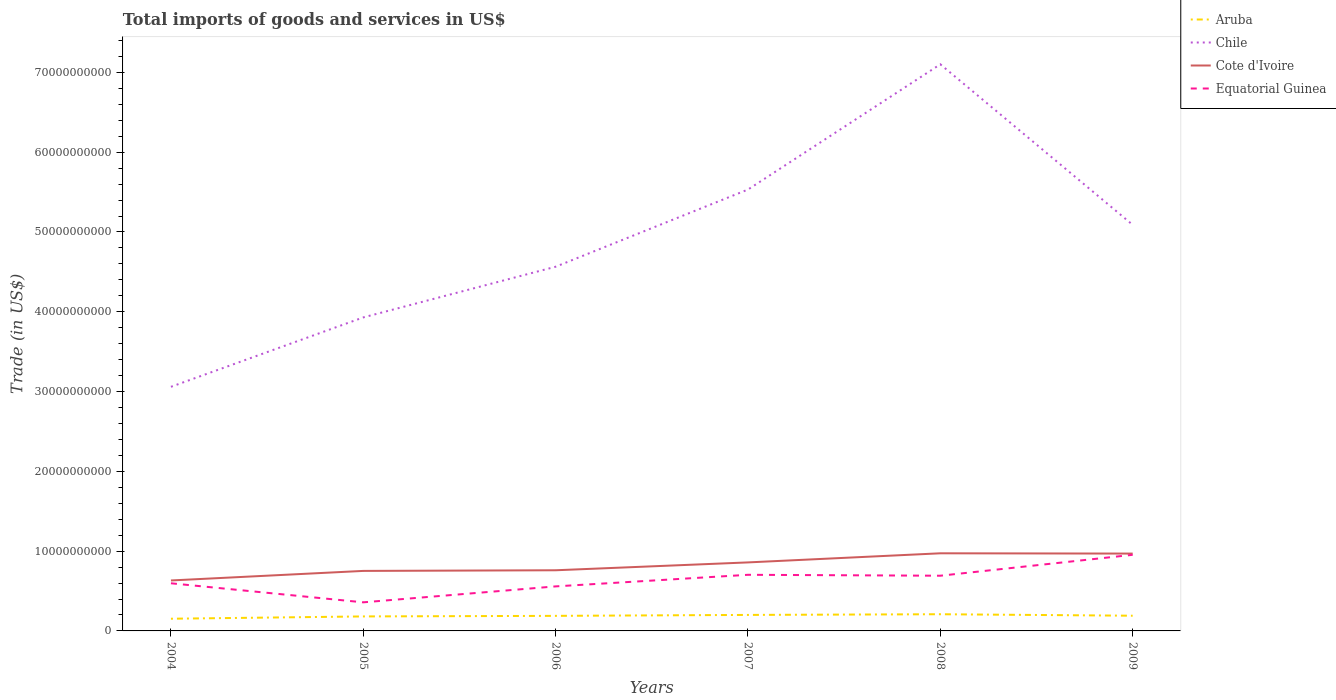Does the line corresponding to Equatorial Guinea intersect with the line corresponding to Aruba?
Your answer should be very brief. No. Across all years, what is the maximum total imports of goods and services in Aruba?
Provide a short and direct response. 1.53e+09. What is the total total imports of goods and services in Aruba in the graph?
Your response must be concise. -2.89e+08. What is the difference between the highest and the second highest total imports of goods and services in Aruba?
Your response must be concise. 5.64e+08. What is the difference between the highest and the lowest total imports of goods and services in Cote d'Ivoire?
Keep it short and to the point. 3. Is the total imports of goods and services in Cote d'Ivoire strictly greater than the total imports of goods and services in Equatorial Guinea over the years?
Keep it short and to the point. No. What is the difference between two consecutive major ticks on the Y-axis?
Your response must be concise. 1.00e+1. Does the graph contain any zero values?
Make the answer very short. No. How many legend labels are there?
Give a very brief answer. 4. How are the legend labels stacked?
Give a very brief answer. Vertical. What is the title of the graph?
Give a very brief answer. Total imports of goods and services in US$. What is the label or title of the X-axis?
Make the answer very short. Years. What is the label or title of the Y-axis?
Keep it short and to the point. Trade (in US$). What is the Trade (in US$) of Aruba in 2004?
Provide a short and direct response. 1.53e+09. What is the Trade (in US$) in Chile in 2004?
Offer a terse response. 3.06e+1. What is the Trade (in US$) of Cote d'Ivoire in 2004?
Give a very brief answer. 6.32e+09. What is the Trade (in US$) in Equatorial Guinea in 2004?
Give a very brief answer. 5.97e+09. What is the Trade (in US$) in Aruba in 2005?
Your response must be concise. 1.82e+09. What is the Trade (in US$) of Chile in 2005?
Keep it short and to the point. 3.93e+1. What is the Trade (in US$) of Cote d'Ivoire in 2005?
Offer a terse response. 7.52e+09. What is the Trade (in US$) of Equatorial Guinea in 2005?
Your answer should be very brief. 3.58e+09. What is the Trade (in US$) in Aruba in 2006?
Offer a terse response. 1.89e+09. What is the Trade (in US$) of Chile in 2006?
Provide a succinct answer. 4.56e+1. What is the Trade (in US$) in Cote d'Ivoire in 2006?
Make the answer very short. 7.60e+09. What is the Trade (in US$) of Equatorial Guinea in 2006?
Provide a succinct answer. 5.58e+09. What is the Trade (in US$) in Aruba in 2007?
Your response must be concise. 2.01e+09. What is the Trade (in US$) in Chile in 2007?
Offer a very short reply. 5.53e+1. What is the Trade (in US$) in Cote d'Ivoire in 2007?
Your response must be concise. 8.59e+09. What is the Trade (in US$) in Equatorial Guinea in 2007?
Your answer should be compact. 7.03e+09. What is the Trade (in US$) of Aruba in 2008?
Keep it short and to the point. 2.09e+09. What is the Trade (in US$) of Chile in 2008?
Keep it short and to the point. 7.10e+1. What is the Trade (in US$) in Cote d'Ivoire in 2008?
Offer a very short reply. 9.73e+09. What is the Trade (in US$) in Equatorial Guinea in 2008?
Provide a short and direct response. 6.92e+09. What is the Trade (in US$) of Aruba in 2009?
Ensure brevity in your answer.  1.91e+09. What is the Trade (in US$) of Chile in 2009?
Your answer should be compact. 5.09e+1. What is the Trade (in US$) of Cote d'Ivoire in 2009?
Provide a short and direct response. 9.69e+09. What is the Trade (in US$) in Equatorial Guinea in 2009?
Make the answer very short. 9.54e+09. Across all years, what is the maximum Trade (in US$) in Aruba?
Make the answer very short. 2.09e+09. Across all years, what is the maximum Trade (in US$) of Chile?
Give a very brief answer. 7.10e+1. Across all years, what is the maximum Trade (in US$) in Cote d'Ivoire?
Keep it short and to the point. 9.73e+09. Across all years, what is the maximum Trade (in US$) of Equatorial Guinea?
Keep it short and to the point. 9.54e+09. Across all years, what is the minimum Trade (in US$) in Aruba?
Keep it short and to the point. 1.53e+09. Across all years, what is the minimum Trade (in US$) of Chile?
Your answer should be compact. 3.06e+1. Across all years, what is the minimum Trade (in US$) of Cote d'Ivoire?
Provide a succinct answer. 6.32e+09. Across all years, what is the minimum Trade (in US$) in Equatorial Guinea?
Your response must be concise. 3.58e+09. What is the total Trade (in US$) in Aruba in the graph?
Ensure brevity in your answer.  1.12e+1. What is the total Trade (in US$) in Chile in the graph?
Offer a very short reply. 2.93e+11. What is the total Trade (in US$) in Cote d'Ivoire in the graph?
Provide a succinct answer. 4.95e+1. What is the total Trade (in US$) of Equatorial Guinea in the graph?
Keep it short and to the point. 3.86e+1. What is the difference between the Trade (in US$) of Aruba in 2004 and that in 2005?
Offer a very short reply. -2.89e+08. What is the difference between the Trade (in US$) in Chile in 2004 and that in 2005?
Ensure brevity in your answer.  -8.70e+09. What is the difference between the Trade (in US$) of Cote d'Ivoire in 2004 and that in 2005?
Offer a very short reply. -1.20e+09. What is the difference between the Trade (in US$) of Equatorial Guinea in 2004 and that in 2005?
Offer a very short reply. 2.39e+09. What is the difference between the Trade (in US$) in Aruba in 2004 and that in 2006?
Offer a terse response. -3.60e+08. What is the difference between the Trade (in US$) in Chile in 2004 and that in 2006?
Offer a terse response. -1.50e+1. What is the difference between the Trade (in US$) in Cote d'Ivoire in 2004 and that in 2006?
Provide a short and direct response. -1.28e+09. What is the difference between the Trade (in US$) of Equatorial Guinea in 2004 and that in 2006?
Provide a succinct answer. 3.90e+08. What is the difference between the Trade (in US$) in Aruba in 2004 and that in 2007?
Offer a terse response. -4.78e+08. What is the difference between the Trade (in US$) in Chile in 2004 and that in 2007?
Ensure brevity in your answer.  -2.47e+1. What is the difference between the Trade (in US$) of Cote d'Ivoire in 2004 and that in 2007?
Offer a very short reply. -2.26e+09. What is the difference between the Trade (in US$) in Equatorial Guinea in 2004 and that in 2007?
Keep it short and to the point. -1.06e+09. What is the difference between the Trade (in US$) in Aruba in 2004 and that in 2008?
Your response must be concise. -5.64e+08. What is the difference between the Trade (in US$) of Chile in 2004 and that in 2008?
Make the answer very short. -4.04e+1. What is the difference between the Trade (in US$) in Cote d'Ivoire in 2004 and that in 2008?
Your answer should be very brief. -3.40e+09. What is the difference between the Trade (in US$) in Equatorial Guinea in 2004 and that in 2008?
Offer a very short reply. -9.47e+08. What is the difference between the Trade (in US$) of Aruba in 2004 and that in 2009?
Ensure brevity in your answer.  -3.78e+08. What is the difference between the Trade (in US$) in Chile in 2004 and that in 2009?
Offer a terse response. -2.03e+1. What is the difference between the Trade (in US$) in Cote d'Ivoire in 2004 and that in 2009?
Keep it short and to the point. -3.37e+09. What is the difference between the Trade (in US$) in Equatorial Guinea in 2004 and that in 2009?
Keep it short and to the point. -3.57e+09. What is the difference between the Trade (in US$) in Aruba in 2005 and that in 2006?
Your response must be concise. -7.15e+07. What is the difference between the Trade (in US$) in Chile in 2005 and that in 2006?
Give a very brief answer. -6.35e+09. What is the difference between the Trade (in US$) of Cote d'Ivoire in 2005 and that in 2006?
Keep it short and to the point. -7.98e+07. What is the difference between the Trade (in US$) in Equatorial Guinea in 2005 and that in 2006?
Provide a short and direct response. -2.00e+09. What is the difference between the Trade (in US$) of Aruba in 2005 and that in 2007?
Ensure brevity in your answer.  -1.89e+08. What is the difference between the Trade (in US$) in Chile in 2005 and that in 2007?
Offer a terse response. -1.60e+1. What is the difference between the Trade (in US$) of Cote d'Ivoire in 2005 and that in 2007?
Offer a terse response. -1.07e+09. What is the difference between the Trade (in US$) in Equatorial Guinea in 2005 and that in 2007?
Offer a very short reply. -3.45e+09. What is the difference between the Trade (in US$) of Aruba in 2005 and that in 2008?
Ensure brevity in your answer.  -2.75e+08. What is the difference between the Trade (in US$) in Chile in 2005 and that in 2008?
Provide a succinct answer. -3.17e+1. What is the difference between the Trade (in US$) of Cote d'Ivoire in 2005 and that in 2008?
Make the answer very short. -2.21e+09. What is the difference between the Trade (in US$) of Equatorial Guinea in 2005 and that in 2008?
Give a very brief answer. -3.34e+09. What is the difference between the Trade (in US$) in Aruba in 2005 and that in 2009?
Your response must be concise. -8.95e+07. What is the difference between the Trade (in US$) of Chile in 2005 and that in 2009?
Offer a terse response. -1.16e+1. What is the difference between the Trade (in US$) of Cote d'Ivoire in 2005 and that in 2009?
Provide a short and direct response. -2.17e+09. What is the difference between the Trade (in US$) in Equatorial Guinea in 2005 and that in 2009?
Your answer should be compact. -5.96e+09. What is the difference between the Trade (in US$) of Aruba in 2006 and that in 2007?
Give a very brief answer. -1.18e+08. What is the difference between the Trade (in US$) in Chile in 2006 and that in 2007?
Your answer should be compact. -9.67e+09. What is the difference between the Trade (in US$) in Cote d'Ivoire in 2006 and that in 2007?
Provide a short and direct response. -9.86e+08. What is the difference between the Trade (in US$) of Equatorial Guinea in 2006 and that in 2007?
Your answer should be very brief. -1.45e+09. What is the difference between the Trade (in US$) of Aruba in 2006 and that in 2008?
Your answer should be very brief. -2.04e+08. What is the difference between the Trade (in US$) in Chile in 2006 and that in 2008?
Your response must be concise. -2.54e+1. What is the difference between the Trade (in US$) in Cote d'Ivoire in 2006 and that in 2008?
Provide a succinct answer. -2.13e+09. What is the difference between the Trade (in US$) of Equatorial Guinea in 2006 and that in 2008?
Provide a short and direct response. -1.34e+09. What is the difference between the Trade (in US$) in Aruba in 2006 and that in 2009?
Your answer should be compact. -1.80e+07. What is the difference between the Trade (in US$) of Chile in 2006 and that in 2009?
Keep it short and to the point. -5.25e+09. What is the difference between the Trade (in US$) of Cote d'Ivoire in 2006 and that in 2009?
Your response must be concise. -2.09e+09. What is the difference between the Trade (in US$) of Equatorial Guinea in 2006 and that in 2009?
Make the answer very short. -3.96e+09. What is the difference between the Trade (in US$) of Aruba in 2007 and that in 2008?
Provide a short and direct response. -8.61e+07. What is the difference between the Trade (in US$) in Chile in 2007 and that in 2008?
Offer a very short reply. -1.57e+1. What is the difference between the Trade (in US$) of Cote d'Ivoire in 2007 and that in 2008?
Provide a succinct answer. -1.14e+09. What is the difference between the Trade (in US$) in Equatorial Guinea in 2007 and that in 2008?
Give a very brief answer. 1.16e+08. What is the difference between the Trade (in US$) of Aruba in 2007 and that in 2009?
Your response must be concise. 9.97e+07. What is the difference between the Trade (in US$) in Chile in 2007 and that in 2009?
Offer a very short reply. 4.42e+09. What is the difference between the Trade (in US$) in Cote d'Ivoire in 2007 and that in 2009?
Your response must be concise. -1.11e+09. What is the difference between the Trade (in US$) in Equatorial Guinea in 2007 and that in 2009?
Provide a succinct answer. -2.51e+09. What is the difference between the Trade (in US$) of Aruba in 2008 and that in 2009?
Your answer should be very brief. 1.86e+08. What is the difference between the Trade (in US$) of Chile in 2008 and that in 2009?
Make the answer very short. 2.01e+1. What is the difference between the Trade (in US$) in Cote d'Ivoire in 2008 and that in 2009?
Make the answer very short. 3.57e+07. What is the difference between the Trade (in US$) of Equatorial Guinea in 2008 and that in 2009?
Provide a short and direct response. -2.62e+09. What is the difference between the Trade (in US$) of Aruba in 2004 and the Trade (in US$) of Chile in 2005?
Offer a very short reply. -3.78e+1. What is the difference between the Trade (in US$) of Aruba in 2004 and the Trade (in US$) of Cote d'Ivoire in 2005?
Your response must be concise. -5.99e+09. What is the difference between the Trade (in US$) of Aruba in 2004 and the Trade (in US$) of Equatorial Guinea in 2005?
Your answer should be very brief. -2.06e+09. What is the difference between the Trade (in US$) in Chile in 2004 and the Trade (in US$) in Cote d'Ivoire in 2005?
Provide a short and direct response. 2.31e+1. What is the difference between the Trade (in US$) in Chile in 2004 and the Trade (in US$) in Equatorial Guinea in 2005?
Provide a succinct answer. 2.70e+1. What is the difference between the Trade (in US$) in Cote d'Ivoire in 2004 and the Trade (in US$) in Equatorial Guinea in 2005?
Your response must be concise. 2.74e+09. What is the difference between the Trade (in US$) in Aruba in 2004 and the Trade (in US$) in Chile in 2006?
Ensure brevity in your answer.  -4.41e+1. What is the difference between the Trade (in US$) in Aruba in 2004 and the Trade (in US$) in Cote d'Ivoire in 2006?
Keep it short and to the point. -6.07e+09. What is the difference between the Trade (in US$) in Aruba in 2004 and the Trade (in US$) in Equatorial Guinea in 2006?
Your response must be concise. -4.05e+09. What is the difference between the Trade (in US$) in Chile in 2004 and the Trade (in US$) in Cote d'Ivoire in 2006?
Give a very brief answer. 2.30e+1. What is the difference between the Trade (in US$) of Chile in 2004 and the Trade (in US$) of Equatorial Guinea in 2006?
Keep it short and to the point. 2.50e+1. What is the difference between the Trade (in US$) of Cote d'Ivoire in 2004 and the Trade (in US$) of Equatorial Guinea in 2006?
Your answer should be compact. 7.43e+08. What is the difference between the Trade (in US$) of Aruba in 2004 and the Trade (in US$) of Chile in 2007?
Your answer should be compact. -5.38e+1. What is the difference between the Trade (in US$) of Aruba in 2004 and the Trade (in US$) of Cote d'Ivoire in 2007?
Provide a short and direct response. -7.06e+09. What is the difference between the Trade (in US$) of Aruba in 2004 and the Trade (in US$) of Equatorial Guinea in 2007?
Your answer should be very brief. -5.51e+09. What is the difference between the Trade (in US$) in Chile in 2004 and the Trade (in US$) in Cote d'Ivoire in 2007?
Provide a short and direct response. 2.20e+1. What is the difference between the Trade (in US$) of Chile in 2004 and the Trade (in US$) of Equatorial Guinea in 2007?
Your response must be concise. 2.36e+1. What is the difference between the Trade (in US$) of Cote d'Ivoire in 2004 and the Trade (in US$) of Equatorial Guinea in 2007?
Make the answer very short. -7.10e+08. What is the difference between the Trade (in US$) in Aruba in 2004 and the Trade (in US$) in Chile in 2008?
Give a very brief answer. -6.95e+1. What is the difference between the Trade (in US$) in Aruba in 2004 and the Trade (in US$) in Cote d'Ivoire in 2008?
Offer a very short reply. -8.20e+09. What is the difference between the Trade (in US$) of Aruba in 2004 and the Trade (in US$) of Equatorial Guinea in 2008?
Offer a very short reply. -5.39e+09. What is the difference between the Trade (in US$) of Chile in 2004 and the Trade (in US$) of Cote d'Ivoire in 2008?
Offer a terse response. 2.09e+1. What is the difference between the Trade (in US$) in Chile in 2004 and the Trade (in US$) in Equatorial Guinea in 2008?
Offer a terse response. 2.37e+1. What is the difference between the Trade (in US$) in Cote d'Ivoire in 2004 and the Trade (in US$) in Equatorial Guinea in 2008?
Your answer should be compact. -5.94e+08. What is the difference between the Trade (in US$) of Aruba in 2004 and the Trade (in US$) of Chile in 2009?
Your answer should be very brief. -4.94e+1. What is the difference between the Trade (in US$) in Aruba in 2004 and the Trade (in US$) in Cote d'Ivoire in 2009?
Keep it short and to the point. -8.16e+09. What is the difference between the Trade (in US$) in Aruba in 2004 and the Trade (in US$) in Equatorial Guinea in 2009?
Keep it short and to the point. -8.01e+09. What is the difference between the Trade (in US$) of Chile in 2004 and the Trade (in US$) of Cote d'Ivoire in 2009?
Your answer should be compact. 2.09e+1. What is the difference between the Trade (in US$) of Chile in 2004 and the Trade (in US$) of Equatorial Guinea in 2009?
Your answer should be very brief. 2.11e+1. What is the difference between the Trade (in US$) of Cote d'Ivoire in 2004 and the Trade (in US$) of Equatorial Guinea in 2009?
Provide a short and direct response. -3.22e+09. What is the difference between the Trade (in US$) of Aruba in 2005 and the Trade (in US$) of Chile in 2006?
Give a very brief answer. -4.38e+1. What is the difference between the Trade (in US$) of Aruba in 2005 and the Trade (in US$) of Cote d'Ivoire in 2006?
Your answer should be compact. -5.78e+09. What is the difference between the Trade (in US$) of Aruba in 2005 and the Trade (in US$) of Equatorial Guinea in 2006?
Ensure brevity in your answer.  -3.76e+09. What is the difference between the Trade (in US$) of Chile in 2005 and the Trade (in US$) of Cote d'Ivoire in 2006?
Give a very brief answer. 3.17e+1. What is the difference between the Trade (in US$) of Chile in 2005 and the Trade (in US$) of Equatorial Guinea in 2006?
Your answer should be compact. 3.37e+1. What is the difference between the Trade (in US$) of Cote d'Ivoire in 2005 and the Trade (in US$) of Equatorial Guinea in 2006?
Ensure brevity in your answer.  1.94e+09. What is the difference between the Trade (in US$) in Aruba in 2005 and the Trade (in US$) in Chile in 2007?
Offer a very short reply. -5.35e+1. What is the difference between the Trade (in US$) in Aruba in 2005 and the Trade (in US$) in Cote d'Ivoire in 2007?
Keep it short and to the point. -6.77e+09. What is the difference between the Trade (in US$) of Aruba in 2005 and the Trade (in US$) of Equatorial Guinea in 2007?
Your response must be concise. -5.22e+09. What is the difference between the Trade (in US$) of Chile in 2005 and the Trade (in US$) of Cote d'Ivoire in 2007?
Your answer should be compact. 3.07e+1. What is the difference between the Trade (in US$) of Chile in 2005 and the Trade (in US$) of Equatorial Guinea in 2007?
Keep it short and to the point. 3.23e+1. What is the difference between the Trade (in US$) in Cote d'Ivoire in 2005 and the Trade (in US$) in Equatorial Guinea in 2007?
Provide a succinct answer. 4.87e+08. What is the difference between the Trade (in US$) in Aruba in 2005 and the Trade (in US$) in Chile in 2008?
Make the answer very short. -6.92e+1. What is the difference between the Trade (in US$) in Aruba in 2005 and the Trade (in US$) in Cote d'Ivoire in 2008?
Make the answer very short. -7.91e+09. What is the difference between the Trade (in US$) of Aruba in 2005 and the Trade (in US$) of Equatorial Guinea in 2008?
Keep it short and to the point. -5.10e+09. What is the difference between the Trade (in US$) of Chile in 2005 and the Trade (in US$) of Cote d'Ivoire in 2008?
Offer a terse response. 2.96e+1. What is the difference between the Trade (in US$) of Chile in 2005 and the Trade (in US$) of Equatorial Guinea in 2008?
Keep it short and to the point. 3.24e+1. What is the difference between the Trade (in US$) of Cote d'Ivoire in 2005 and the Trade (in US$) of Equatorial Guinea in 2008?
Provide a short and direct response. 6.03e+08. What is the difference between the Trade (in US$) of Aruba in 2005 and the Trade (in US$) of Chile in 2009?
Offer a terse response. -4.91e+1. What is the difference between the Trade (in US$) in Aruba in 2005 and the Trade (in US$) in Cote d'Ivoire in 2009?
Your response must be concise. -7.88e+09. What is the difference between the Trade (in US$) of Aruba in 2005 and the Trade (in US$) of Equatorial Guinea in 2009?
Your response must be concise. -7.72e+09. What is the difference between the Trade (in US$) of Chile in 2005 and the Trade (in US$) of Cote d'Ivoire in 2009?
Offer a very short reply. 2.96e+1. What is the difference between the Trade (in US$) of Chile in 2005 and the Trade (in US$) of Equatorial Guinea in 2009?
Your answer should be very brief. 2.98e+1. What is the difference between the Trade (in US$) of Cote d'Ivoire in 2005 and the Trade (in US$) of Equatorial Guinea in 2009?
Provide a short and direct response. -2.02e+09. What is the difference between the Trade (in US$) of Aruba in 2006 and the Trade (in US$) of Chile in 2007?
Your answer should be very brief. -5.34e+1. What is the difference between the Trade (in US$) in Aruba in 2006 and the Trade (in US$) in Cote d'Ivoire in 2007?
Provide a short and direct response. -6.70e+09. What is the difference between the Trade (in US$) in Aruba in 2006 and the Trade (in US$) in Equatorial Guinea in 2007?
Provide a succinct answer. -5.15e+09. What is the difference between the Trade (in US$) in Chile in 2006 and the Trade (in US$) in Cote d'Ivoire in 2007?
Ensure brevity in your answer.  3.71e+1. What is the difference between the Trade (in US$) in Chile in 2006 and the Trade (in US$) in Equatorial Guinea in 2007?
Provide a succinct answer. 3.86e+1. What is the difference between the Trade (in US$) in Cote d'Ivoire in 2006 and the Trade (in US$) in Equatorial Guinea in 2007?
Ensure brevity in your answer.  5.67e+08. What is the difference between the Trade (in US$) of Aruba in 2006 and the Trade (in US$) of Chile in 2008?
Keep it short and to the point. -6.91e+1. What is the difference between the Trade (in US$) in Aruba in 2006 and the Trade (in US$) in Cote d'Ivoire in 2008?
Your answer should be compact. -7.84e+09. What is the difference between the Trade (in US$) of Aruba in 2006 and the Trade (in US$) of Equatorial Guinea in 2008?
Make the answer very short. -5.03e+09. What is the difference between the Trade (in US$) in Chile in 2006 and the Trade (in US$) in Cote d'Ivoire in 2008?
Make the answer very short. 3.59e+1. What is the difference between the Trade (in US$) in Chile in 2006 and the Trade (in US$) in Equatorial Guinea in 2008?
Your answer should be compact. 3.87e+1. What is the difference between the Trade (in US$) in Cote d'Ivoire in 2006 and the Trade (in US$) in Equatorial Guinea in 2008?
Provide a short and direct response. 6.83e+08. What is the difference between the Trade (in US$) of Aruba in 2006 and the Trade (in US$) of Chile in 2009?
Make the answer very short. -4.90e+1. What is the difference between the Trade (in US$) in Aruba in 2006 and the Trade (in US$) in Cote d'Ivoire in 2009?
Make the answer very short. -7.80e+09. What is the difference between the Trade (in US$) in Aruba in 2006 and the Trade (in US$) in Equatorial Guinea in 2009?
Ensure brevity in your answer.  -7.65e+09. What is the difference between the Trade (in US$) of Chile in 2006 and the Trade (in US$) of Cote d'Ivoire in 2009?
Keep it short and to the point. 3.60e+1. What is the difference between the Trade (in US$) of Chile in 2006 and the Trade (in US$) of Equatorial Guinea in 2009?
Ensure brevity in your answer.  3.61e+1. What is the difference between the Trade (in US$) of Cote d'Ivoire in 2006 and the Trade (in US$) of Equatorial Guinea in 2009?
Offer a very short reply. -1.94e+09. What is the difference between the Trade (in US$) in Aruba in 2007 and the Trade (in US$) in Chile in 2008?
Your answer should be compact. -6.90e+1. What is the difference between the Trade (in US$) of Aruba in 2007 and the Trade (in US$) of Cote d'Ivoire in 2008?
Make the answer very short. -7.72e+09. What is the difference between the Trade (in US$) of Aruba in 2007 and the Trade (in US$) of Equatorial Guinea in 2008?
Your response must be concise. -4.91e+09. What is the difference between the Trade (in US$) of Chile in 2007 and the Trade (in US$) of Cote d'Ivoire in 2008?
Offer a very short reply. 4.56e+1. What is the difference between the Trade (in US$) of Chile in 2007 and the Trade (in US$) of Equatorial Guinea in 2008?
Ensure brevity in your answer.  4.84e+1. What is the difference between the Trade (in US$) of Cote d'Ivoire in 2007 and the Trade (in US$) of Equatorial Guinea in 2008?
Offer a terse response. 1.67e+09. What is the difference between the Trade (in US$) of Aruba in 2007 and the Trade (in US$) of Chile in 2009?
Keep it short and to the point. -4.89e+1. What is the difference between the Trade (in US$) in Aruba in 2007 and the Trade (in US$) in Cote d'Ivoire in 2009?
Make the answer very short. -7.69e+09. What is the difference between the Trade (in US$) of Aruba in 2007 and the Trade (in US$) of Equatorial Guinea in 2009?
Offer a terse response. -7.53e+09. What is the difference between the Trade (in US$) of Chile in 2007 and the Trade (in US$) of Cote d'Ivoire in 2009?
Your answer should be compact. 4.56e+1. What is the difference between the Trade (in US$) in Chile in 2007 and the Trade (in US$) in Equatorial Guinea in 2009?
Offer a terse response. 4.58e+1. What is the difference between the Trade (in US$) of Cote d'Ivoire in 2007 and the Trade (in US$) of Equatorial Guinea in 2009?
Provide a succinct answer. -9.52e+08. What is the difference between the Trade (in US$) in Aruba in 2008 and the Trade (in US$) in Chile in 2009?
Provide a succinct answer. -4.88e+1. What is the difference between the Trade (in US$) in Aruba in 2008 and the Trade (in US$) in Cote d'Ivoire in 2009?
Your response must be concise. -7.60e+09. What is the difference between the Trade (in US$) of Aruba in 2008 and the Trade (in US$) of Equatorial Guinea in 2009?
Your answer should be compact. -7.45e+09. What is the difference between the Trade (in US$) in Chile in 2008 and the Trade (in US$) in Cote d'Ivoire in 2009?
Offer a very short reply. 6.13e+1. What is the difference between the Trade (in US$) of Chile in 2008 and the Trade (in US$) of Equatorial Guinea in 2009?
Provide a succinct answer. 6.15e+1. What is the difference between the Trade (in US$) in Cote d'Ivoire in 2008 and the Trade (in US$) in Equatorial Guinea in 2009?
Your answer should be very brief. 1.89e+08. What is the average Trade (in US$) of Aruba per year?
Your answer should be very brief. 1.87e+09. What is the average Trade (in US$) of Chile per year?
Your answer should be very brief. 4.88e+1. What is the average Trade (in US$) of Cote d'Ivoire per year?
Make the answer very short. 8.24e+09. What is the average Trade (in US$) in Equatorial Guinea per year?
Your answer should be compact. 6.44e+09. In the year 2004, what is the difference between the Trade (in US$) in Aruba and Trade (in US$) in Chile?
Provide a succinct answer. -2.91e+1. In the year 2004, what is the difference between the Trade (in US$) of Aruba and Trade (in US$) of Cote d'Ivoire?
Provide a succinct answer. -4.80e+09. In the year 2004, what is the difference between the Trade (in US$) in Aruba and Trade (in US$) in Equatorial Guinea?
Provide a succinct answer. -4.44e+09. In the year 2004, what is the difference between the Trade (in US$) in Chile and Trade (in US$) in Cote d'Ivoire?
Provide a succinct answer. 2.43e+1. In the year 2004, what is the difference between the Trade (in US$) in Chile and Trade (in US$) in Equatorial Guinea?
Offer a very short reply. 2.46e+1. In the year 2004, what is the difference between the Trade (in US$) in Cote d'Ivoire and Trade (in US$) in Equatorial Guinea?
Give a very brief answer. 3.53e+08. In the year 2005, what is the difference between the Trade (in US$) of Aruba and Trade (in US$) of Chile?
Give a very brief answer. -3.75e+1. In the year 2005, what is the difference between the Trade (in US$) of Aruba and Trade (in US$) of Cote d'Ivoire?
Provide a succinct answer. -5.70e+09. In the year 2005, what is the difference between the Trade (in US$) in Aruba and Trade (in US$) in Equatorial Guinea?
Give a very brief answer. -1.77e+09. In the year 2005, what is the difference between the Trade (in US$) of Chile and Trade (in US$) of Cote d'Ivoire?
Your answer should be very brief. 3.18e+1. In the year 2005, what is the difference between the Trade (in US$) in Chile and Trade (in US$) in Equatorial Guinea?
Make the answer very short. 3.57e+1. In the year 2005, what is the difference between the Trade (in US$) in Cote d'Ivoire and Trade (in US$) in Equatorial Guinea?
Your answer should be compact. 3.94e+09. In the year 2006, what is the difference between the Trade (in US$) of Aruba and Trade (in US$) of Chile?
Provide a succinct answer. -4.38e+1. In the year 2006, what is the difference between the Trade (in US$) in Aruba and Trade (in US$) in Cote d'Ivoire?
Offer a terse response. -5.71e+09. In the year 2006, what is the difference between the Trade (in US$) in Aruba and Trade (in US$) in Equatorial Guinea?
Your answer should be very brief. -3.69e+09. In the year 2006, what is the difference between the Trade (in US$) of Chile and Trade (in US$) of Cote d'Ivoire?
Your answer should be very brief. 3.80e+1. In the year 2006, what is the difference between the Trade (in US$) of Chile and Trade (in US$) of Equatorial Guinea?
Your answer should be very brief. 4.01e+1. In the year 2006, what is the difference between the Trade (in US$) of Cote d'Ivoire and Trade (in US$) of Equatorial Guinea?
Give a very brief answer. 2.02e+09. In the year 2007, what is the difference between the Trade (in US$) of Aruba and Trade (in US$) of Chile?
Your answer should be compact. -5.33e+1. In the year 2007, what is the difference between the Trade (in US$) in Aruba and Trade (in US$) in Cote d'Ivoire?
Provide a succinct answer. -6.58e+09. In the year 2007, what is the difference between the Trade (in US$) of Aruba and Trade (in US$) of Equatorial Guinea?
Provide a succinct answer. -5.03e+09. In the year 2007, what is the difference between the Trade (in US$) in Chile and Trade (in US$) in Cote d'Ivoire?
Your answer should be very brief. 4.67e+1. In the year 2007, what is the difference between the Trade (in US$) of Chile and Trade (in US$) of Equatorial Guinea?
Make the answer very short. 4.83e+1. In the year 2007, what is the difference between the Trade (in US$) of Cote d'Ivoire and Trade (in US$) of Equatorial Guinea?
Offer a terse response. 1.55e+09. In the year 2008, what is the difference between the Trade (in US$) in Aruba and Trade (in US$) in Chile?
Offer a very short reply. -6.89e+1. In the year 2008, what is the difference between the Trade (in US$) of Aruba and Trade (in US$) of Cote d'Ivoire?
Offer a terse response. -7.64e+09. In the year 2008, what is the difference between the Trade (in US$) of Aruba and Trade (in US$) of Equatorial Guinea?
Provide a succinct answer. -4.83e+09. In the year 2008, what is the difference between the Trade (in US$) in Chile and Trade (in US$) in Cote d'Ivoire?
Keep it short and to the point. 6.13e+1. In the year 2008, what is the difference between the Trade (in US$) of Chile and Trade (in US$) of Equatorial Guinea?
Give a very brief answer. 6.41e+1. In the year 2008, what is the difference between the Trade (in US$) of Cote d'Ivoire and Trade (in US$) of Equatorial Guinea?
Provide a short and direct response. 2.81e+09. In the year 2009, what is the difference between the Trade (in US$) of Aruba and Trade (in US$) of Chile?
Provide a short and direct response. -4.90e+1. In the year 2009, what is the difference between the Trade (in US$) of Aruba and Trade (in US$) of Cote d'Ivoire?
Offer a terse response. -7.79e+09. In the year 2009, what is the difference between the Trade (in US$) of Aruba and Trade (in US$) of Equatorial Guinea?
Make the answer very short. -7.63e+09. In the year 2009, what is the difference between the Trade (in US$) in Chile and Trade (in US$) in Cote d'Ivoire?
Offer a terse response. 4.12e+1. In the year 2009, what is the difference between the Trade (in US$) of Chile and Trade (in US$) of Equatorial Guinea?
Offer a terse response. 4.14e+1. In the year 2009, what is the difference between the Trade (in US$) of Cote d'Ivoire and Trade (in US$) of Equatorial Guinea?
Your response must be concise. 1.53e+08. What is the ratio of the Trade (in US$) in Aruba in 2004 to that in 2005?
Offer a terse response. 0.84. What is the ratio of the Trade (in US$) of Chile in 2004 to that in 2005?
Give a very brief answer. 0.78. What is the ratio of the Trade (in US$) in Cote d'Ivoire in 2004 to that in 2005?
Provide a short and direct response. 0.84. What is the ratio of the Trade (in US$) of Equatorial Guinea in 2004 to that in 2005?
Ensure brevity in your answer.  1.67. What is the ratio of the Trade (in US$) in Aruba in 2004 to that in 2006?
Your response must be concise. 0.81. What is the ratio of the Trade (in US$) in Chile in 2004 to that in 2006?
Offer a very short reply. 0.67. What is the ratio of the Trade (in US$) in Cote d'Ivoire in 2004 to that in 2006?
Ensure brevity in your answer.  0.83. What is the ratio of the Trade (in US$) of Equatorial Guinea in 2004 to that in 2006?
Offer a terse response. 1.07. What is the ratio of the Trade (in US$) of Aruba in 2004 to that in 2007?
Keep it short and to the point. 0.76. What is the ratio of the Trade (in US$) in Chile in 2004 to that in 2007?
Your answer should be very brief. 0.55. What is the ratio of the Trade (in US$) of Cote d'Ivoire in 2004 to that in 2007?
Your answer should be compact. 0.74. What is the ratio of the Trade (in US$) of Equatorial Guinea in 2004 to that in 2007?
Keep it short and to the point. 0.85. What is the ratio of the Trade (in US$) in Aruba in 2004 to that in 2008?
Give a very brief answer. 0.73. What is the ratio of the Trade (in US$) of Chile in 2004 to that in 2008?
Provide a succinct answer. 0.43. What is the ratio of the Trade (in US$) in Cote d'Ivoire in 2004 to that in 2008?
Provide a succinct answer. 0.65. What is the ratio of the Trade (in US$) in Equatorial Guinea in 2004 to that in 2008?
Make the answer very short. 0.86. What is the ratio of the Trade (in US$) in Aruba in 2004 to that in 2009?
Offer a terse response. 0.8. What is the ratio of the Trade (in US$) of Chile in 2004 to that in 2009?
Your response must be concise. 0.6. What is the ratio of the Trade (in US$) of Cote d'Ivoire in 2004 to that in 2009?
Provide a succinct answer. 0.65. What is the ratio of the Trade (in US$) of Equatorial Guinea in 2004 to that in 2009?
Ensure brevity in your answer.  0.63. What is the ratio of the Trade (in US$) of Aruba in 2005 to that in 2006?
Provide a succinct answer. 0.96. What is the ratio of the Trade (in US$) of Chile in 2005 to that in 2006?
Keep it short and to the point. 0.86. What is the ratio of the Trade (in US$) of Equatorial Guinea in 2005 to that in 2006?
Offer a very short reply. 0.64. What is the ratio of the Trade (in US$) of Aruba in 2005 to that in 2007?
Give a very brief answer. 0.91. What is the ratio of the Trade (in US$) in Chile in 2005 to that in 2007?
Your answer should be very brief. 0.71. What is the ratio of the Trade (in US$) of Cote d'Ivoire in 2005 to that in 2007?
Your response must be concise. 0.88. What is the ratio of the Trade (in US$) of Equatorial Guinea in 2005 to that in 2007?
Provide a short and direct response. 0.51. What is the ratio of the Trade (in US$) of Aruba in 2005 to that in 2008?
Give a very brief answer. 0.87. What is the ratio of the Trade (in US$) of Chile in 2005 to that in 2008?
Offer a very short reply. 0.55. What is the ratio of the Trade (in US$) in Cote d'Ivoire in 2005 to that in 2008?
Give a very brief answer. 0.77. What is the ratio of the Trade (in US$) in Equatorial Guinea in 2005 to that in 2008?
Offer a very short reply. 0.52. What is the ratio of the Trade (in US$) of Aruba in 2005 to that in 2009?
Offer a terse response. 0.95. What is the ratio of the Trade (in US$) of Chile in 2005 to that in 2009?
Your answer should be very brief. 0.77. What is the ratio of the Trade (in US$) in Cote d'Ivoire in 2005 to that in 2009?
Offer a very short reply. 0.78. What is the ratio of the Trade (in US$) in Equatorial Guinea in 2005 to that in 2009?
Make the answer very short. 0.38. What is the ratio of the Trade (in US$) of Aruba in 2006 to that in 2007?
Make the answer very short. 0.94. What is the ratio of the Trade (in US$) in Chile in 2006 to that in 2007?
Your answer should be compact. 0.83. What is the ratio of the Trade (in US$) in Cote d'Ivoire in 2006 to that in 2007?
Provide a short and direct response. 0.89. What is the ratio of the Trade (in US$) of Equatorial Guinea in 2006 to that in 2007?
Provide a succinct answer. 0.79. What is the ratio of the Trade (in US$) in Aruba in 2006 to that in 2008?
Keep it short and to the point. 0.9. What is the ratio of the Trade (in US$) in Chile in 2006 to that in 2008?
Your answer should be compact. 0.64. What is the ratio of the Trade (in US$) in Cote d'Ivoire in 2006 to that in 2008?
Keep it short and to the point. 0.78. What is the ratio of the Trade (in US$) in Equatorial Guinea in 2006 to that in 2008?
Your answer should be compact. 0.81. What is the ratio of the Trade (in US$) in Aruba in 2006 to that in 2009?
Offer a very short reply. 0.99. What is the ratio of the Trade (in US$) of Chile in 2006 to that in 2009?
Offer a terse response. 0.9. What is the ratio of the Trade (in US$) in Cote d'Ivoire in 2006 to that in 2009?
Offer a very short reply. 0.78. What is the ratio of the Trade (in US$) in Equatorial Guinea in 2006 to that in 2009?
Make the answer very short. 0.59. What is the ratio of the Trade (in US$) of Aruba in 2007 to that in 2008?
Offer a terse response. 0.96. What is the ratio of the Trade (in US$) of Chile in 2007 to that in 2008?
Your answer should be compact. 0.78. What is the ratio of the Trade (in US$) of Cote d'Ivoire in 2007 to that in 2008?
Provide a succinct answer. 0.88. What is the ratio of the Trade (in US$) of Equatorial Guinea in 2007 to that in 2008?
Provide a succinct answer. 1.02. What is the ratio of the Trade (in US$) in Aruba in 2007 to that in 2009?
Your response must be concise. 1.05. What is the ratio of the Trade (in US$) in Chile in 2007 to that in 2009?
Offer a very short reply. 1.09. What is the ratio of the Trade (in US$) of Cote d'Ivoire in 2007 to that in 2009?
Make the answer very short. 0.89. What is the ratio of the Trade (in US$) in Equatorial Guinea in 2007 to that in 2009?
Offer a terse response. 0.74. What is the ratio of the Trade (in US$) of Aruba in 2008 to that in 2009?
Offer a terse response. 1.1. What is the ratio of the Trade (in US$) in Chile in 2008 to that in 2009?
Your answer should be compact. 1.4. What is the ratio of the Trade (in US$) in Equatorial Guinea in 2008 to that in 2009?
Your response must be concise. 0.73. What is the difference between the highest and the second highest Trade (in US$) in Aruba?
Make the answer very short. 8.61e+07. What is the difference between the highest and the second highest Trade (in US$) of Chile?
Your response must be concise. 1.57e+1. What is the difference between the highest and the second highest Trade (in US$) of Cote d'Ivoire?
Offer a very short reply. 3.57e+07. What is the difference between the highest and the second highest Trade (in US$) in Equatorial Guinea?
Provide a succinct answer. 2.51e+09. What is the difference between the highest and the lowest Trade (in US$) of Aruba?
Ensure brevity in your answer.  5.64e+08. What is the difference between the highest and the lowest Trade (in US$) of Chile?
Your answer should be very brief. 4.04e+1. What is the difference between the highest and the lowest Trade (in US$) of Cote d'Ivoire?
Offer a very short reply. 3.40e+09. What is the difference between the highest and the lowest Trade (in US$) of Equatorial Guinea?
Give a very brief answer. 5.96e+09. 